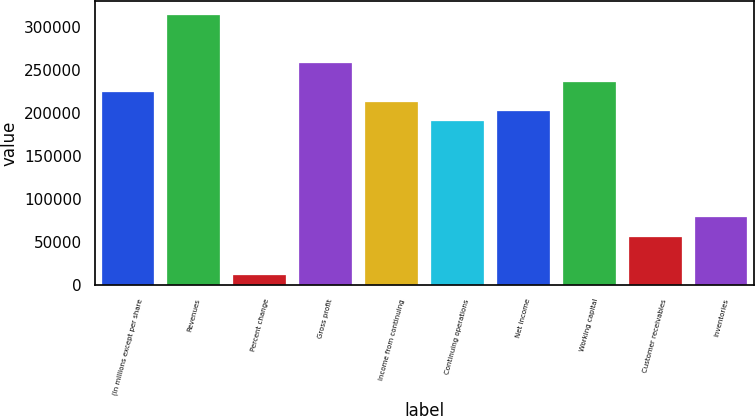Convert chart to OTSL. <chart><loc_0><loc_0><loc_500><loc_500><bar_chart><fcel>(In millions except per share<fcel>Revenues<fcel>Percent change<fcel>Gross profit<fcel>Income from continuing<fcel>Continuing operations<fcel>Net income<fcel>Working capital<fcel>Customer receivables<fcel>Inventories<nl><fcel>224167<fcel>313834<fcel>11209<fcel>257792<fcel>212959<fcel>190542<fcel>201751<fcel>235376<fcel>56042.4<fcel>78459<nl></chart> 